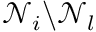<formula> <loc_0><loc_0><loc_500><loc_500>\mathcal { N } _ { i } \ \mathcal { N } _ { l }</formula> 